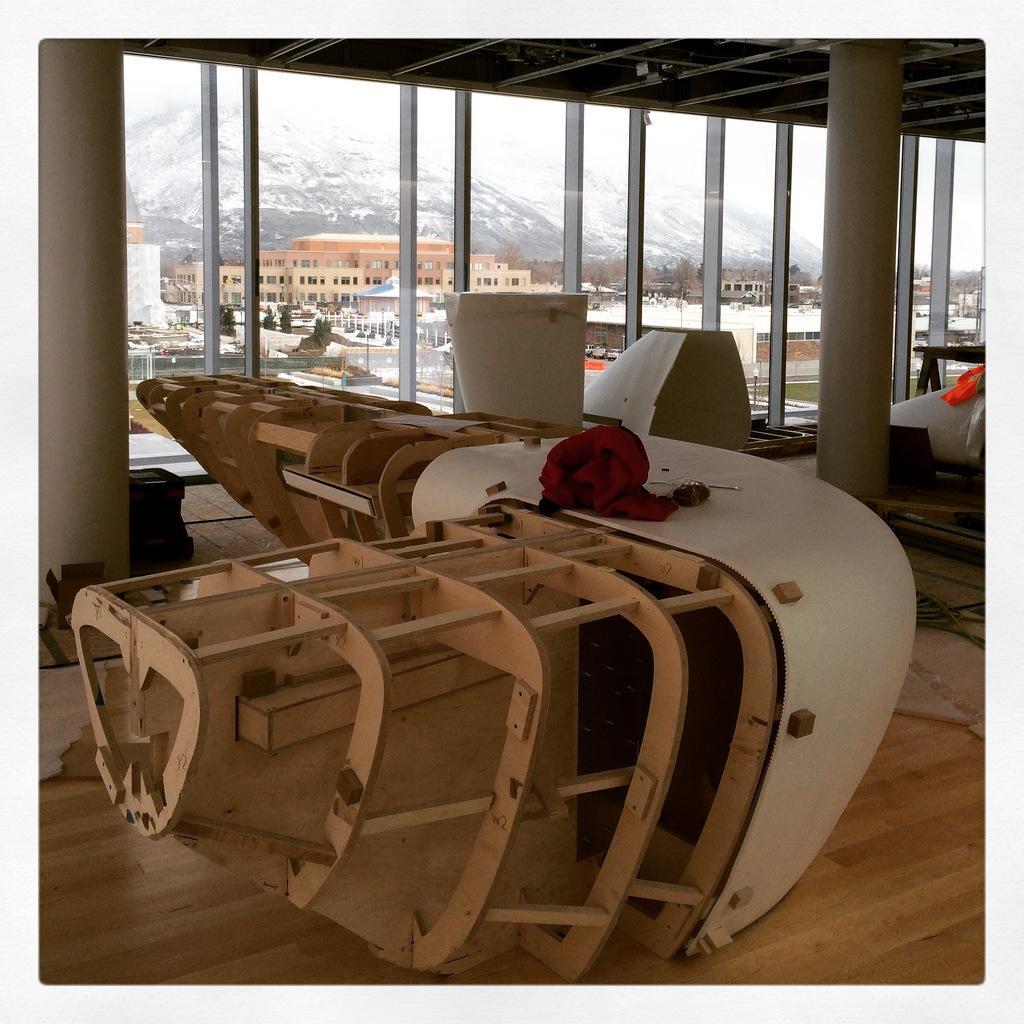How would you summarize this image in a sentence or two? In this image I can see the wooden object. On the wooden object I can see the red color cloth. In the background I can see the glass wall, few buildings in brown and cream color and I can also see the mountains and the sky is in white color. 